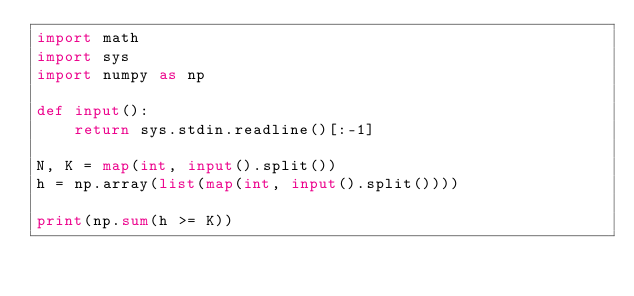<code> <loc_0><loc_0><loc_500><loc_500><_Python_>import math
import sys
import numpy as np

def input():
    return sys.stdin.readline()[:-1]

N, K = map(int, input().split())
h = np.array(list(map(int, input().split())))

print(np.sum(h >= K))
</code> 